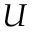Convert formula to latex. <formula><loc_0><loc_0><loc_500><loc_500>U</formula> 